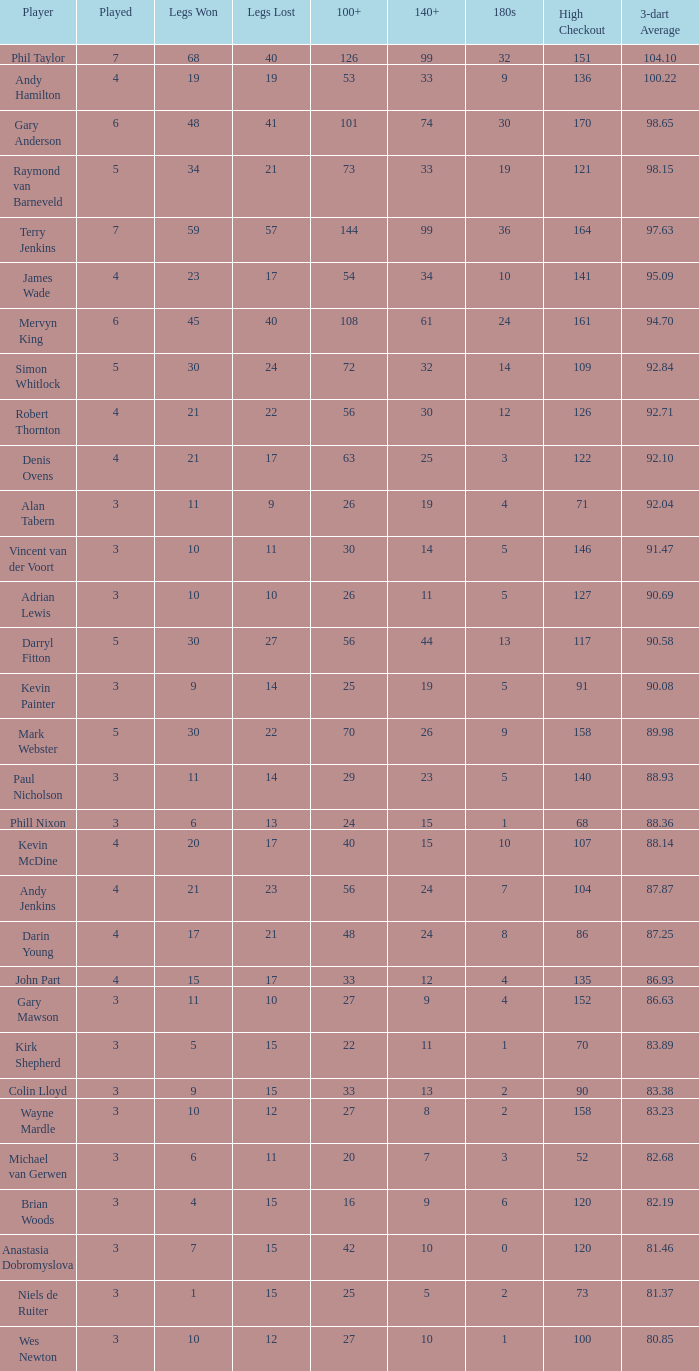Would you mind parsing the complete table? {'header': ['Player', 'Played', 'Legs Won', 'Legs Lost', '100+', '140+', '180s', 'High Checkout', '3-dart Average'], 'rows': [['Phil Taylor', '7', '68', '40', '126', '99', '32', '151', '104.10'], ['Andy Hamilton', '4', '19', '19', '53', '33', '9', '136', '100.22'], ['Gary Anderson', '6', '48', '41', '101', '74', '30', '170', '98.65'], ['Raymond van Barneveld', '5', '34', '21', '73', '33', '19', '121', '98.15'], ['Terry Jenkins', '7', '59', '57', '144', '99', '36', '164', '97.63'], ['James Wade', '4', '23', '17', '54', '34', '10', '141', '95.09'], ['Mervyn King', '6', '45', '40', '108', '61', '24', '161', '94.70'], ['Simon Whitlock', '5', '30', '24', '72', '32', '14', '109', '92.84'], ['Robert Thornton', '4', '21', '22', '56', '30', '12', '126', '92.71'], ['Denis Ovens', '4', '21', '17', '63', '25', '3', '122', '92.10'], ['Alan Tabern', '3', '11', '9', '26', '19', '4', '71', '92.04'], ['Vincent van der Voort', '3', '10', '11', '30', '14', '5', '146', '91.47'], ['Adrian Lewis', '3', '10', '10', '26', '11', '5', '127', '90.69'], ['Darryl Fitton', '5', '30', '27', '56', '44', '13', '117', '90.58'], ['Kevin Painter', '3', '9', '14', '25', '19', '5', '91', '90.08'], ['Mark Webster', '5', '30', '22', '70', '26', '9', '158', '89.98'], ['Paul Nicholson', '3', '11', '14', '29', '23', '5', '140', '88.93'], ['Phill Nixon', '3', '6', '13', '24', '15', '1', '68', '88.36'], ['Kevin McDine', '4', '20', '17', '40', '15', '10', '107', '88.14'], ['Andy Jenkins', '4', '21', '23', '56', '24', '7', '104', '87.87'], ['Darin Young', '4', '17', '21', '48', '24', '8', '86', '87.25'], ['John Part', '4', '15', '17', '33', '12', '4', '135', '86.93'], ['Gary Mawson', '3', '11', '10', '27', '9', '4', '152', '86.63'], ['Kirk Shepherd', '3', '5', '15', '22', '11', '1', '70', '83.89'], ['Colin Lloyd', '3', '9', '15', '33', '13', '2', '90', '83.38'], ['Wayne Mardle', '3', '10', '12', '27', '8', '2', '158', '83.23'], ['Michael van Gerwen', '3', '6', '11', '20', '7', '3', '52', '82.68'], ['Brian Woods', '3', '4', '15', '16', '9', '6', '120', '82.19'], ['Anastasia Dobromyslova', '3', '7', '15', '42', '10', '0', '120', '81.46'], ['Niels de Ruiter', '3', '1', '15', '25', '5', '2', '73', '81.37'], ['Wes Newton', '3', '10', '12', '27', '10', '1', '100', '80.85']]} What is the maximum number of legs lost overall? 57.0. 